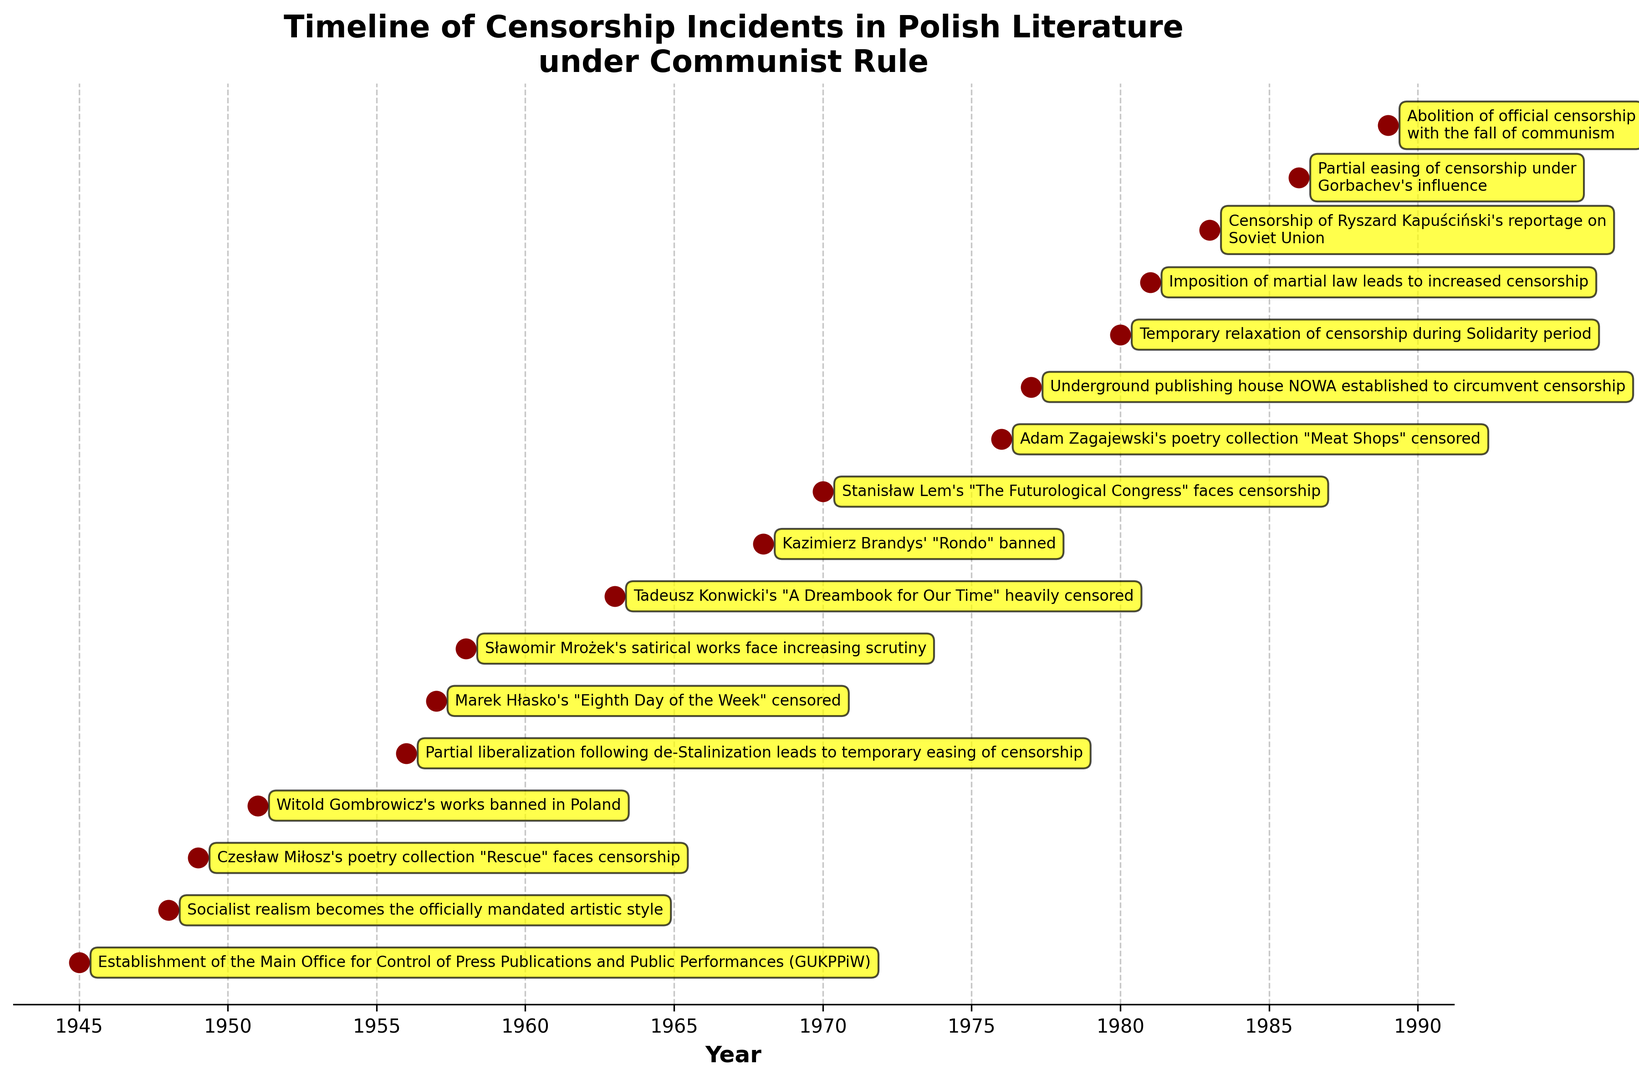What is the title of the plot? The title of the plot is typically found at the top center of the figure, describing the content of the plot. Here, it reads "Timeline of Censorship Incidents in Polish Literature under Communist Rule".
Answer: Timeline of Censorship Incidents in Polish Literature under Communist Rule When was the Main Office for Control of Press Publications and Public Performances (GUKPPiW) established? Identify the first event on the timeline, which marks the establishment of this office. This event is associated with the year 1945.
Answer: 1945 Which two years saw events related to increased censorship triggered by political shifts or crises? Look for annotations that indicate political causes for heightened censorship, such as martial law or leadership changes. The two years are 1981 (martial law) and 1983 (censorship of reportage on the Soviet Union).
Answer: 1981, 1983 How many events in the 1950s are listed on the timeline? Count the number of data points (events) annotated in the 1950s. There are four events: 1951 (Witold Gombrowicz's works banned), 1956 (de-Stalinization easing), 1957 (Marek Hłasko’s censorship), and 1958 (Sławomir Mrożek’s scrutiny).
Answer: 4 Which author's works were censored first according to the timeline? Identify the earliest event on the timeline related to the censorship of a specific author's works. Czesław Miłosz's poetry collection "Rescue" in 1949 is the first instance.
Answer: Czesław Miłosz What is the color used to denote the events on the timeline? Observe the color of the scatter points marking the events in the timeline. All events are denoted using a dark red color.
Answer: Dark red Which year corresponds to the censorship of Tadeusz Konwicki's "A Dreambook for Our Time"? Locate the annotation for Tadeusz Konwicki's "A Dreambook for Our Time" and note the associated year. The year is 1963.
Answer: 1963 What significant event relating to censorship happened in 1989? Identify the event annotated in 1989 on the timeline. The event is the "Abolition of official censorship with the fall of communism".
Answer: Abolition of official censorship Which period saw a temporary relaxation of censorship? Look for annotations indicating temporary easing of censorship and identify the period. It occurred during the Solidarity period in 1980.
Answer: 1980 Compare the number of banned works in the 1940s to the 1970s. Which decade had more incidents? Count the number of annotated banned works in both decades. In the 1940s, there are 2 incidents: "1949 (Czesław Miłosz)" and "1948 (socialist realism)". In the 1970s, there are 2 as well: "1970 (Stanisław Lem)" and "1976 (Adam Zagajewski)", plus the establishment of NOWA in 1977.
Answer: Equal (2 incidents each, plus establishment of NOWA in 1977) 